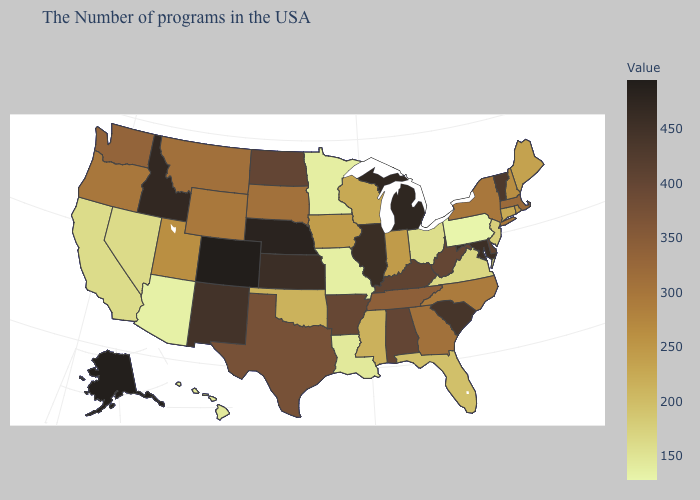Among the states that border Connecticut , does New York have the highest value?
Answer briefly. No. Does Pennsylvania have the lowest value in the USA?
Give a very brief answer. Yes. Does Colorado have the highest value in the USA?
Concise answer only. Yes. Does Missouri have a higher value than Idaho?
Quick response, please. No. 